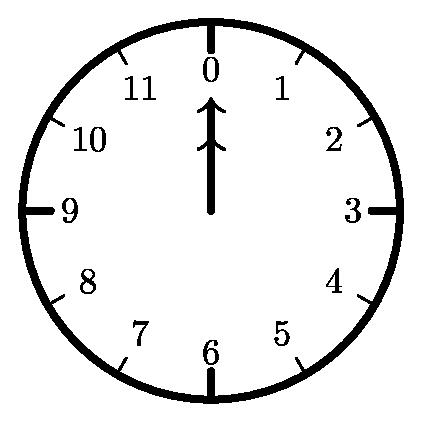Can you guide me on how you would start solving the combinatorial problem presented by this clock image? To begin solving a combinatorial problem like this, I would represent the clock as a graph with nodes corresponding to numbers on the clock face. There are two types of nodes, one for each hand. Then, I'd use combinatorics to find all possible unique sequences where the positions of both hands are covered exactly once. Considering that each number on the clock face can be reached from any other number, and counting all possible sequences with an equal number of moves for each hand, while ensuring they return to 12, would give us the total number N. 